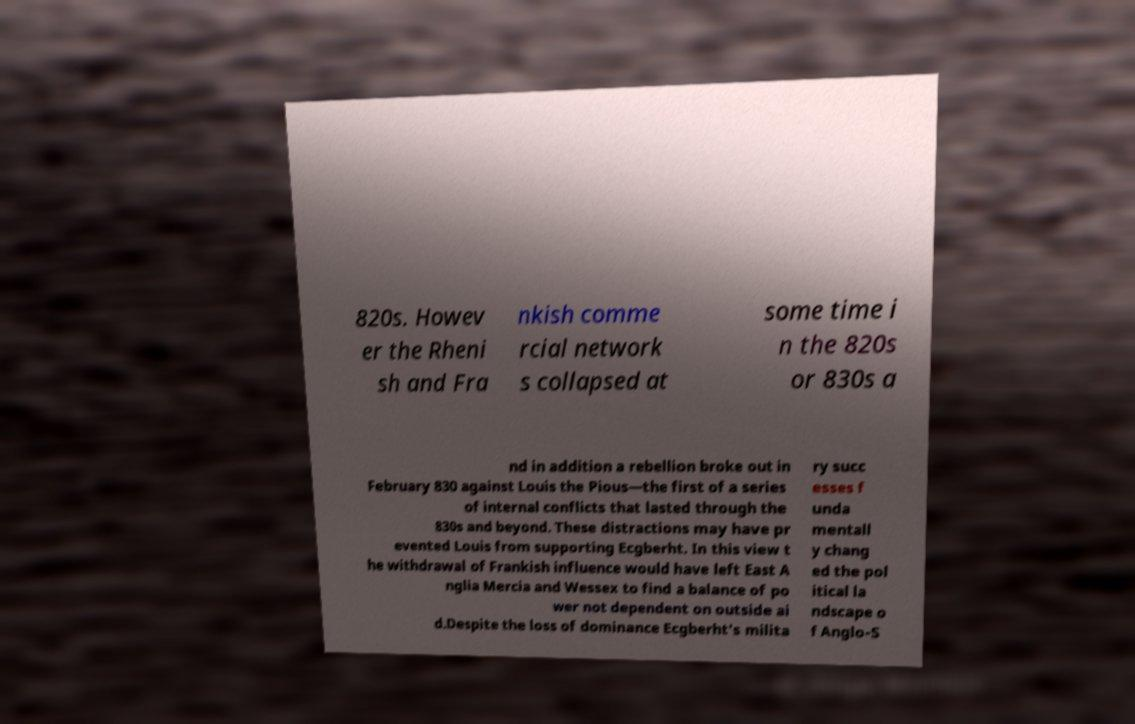For documentation purposes, I need the text within this image transcribed. Could you provide that? 820s. Howev er the Rheni sh and Fra nkish comme rcial network s collapsed at some time i n the 820s or 830s a nd in addition a rebellion broke out in February 830 against Louis the Pious—the first of a series of internal conflicts that lasted through the 830s and beyond. These distractions may have pr evented Louis from supporting Ecgberht. In this view t he withdrawal of Frankish influence would have left East A nglia Mercia and Wessex to find a balance of po wer not dependent on outside ai d.Despite the loss of dominance Ecgberht's milita ry succ esses f unda mentall y chang ed the pol itical la ndscape o f Anglo-S 